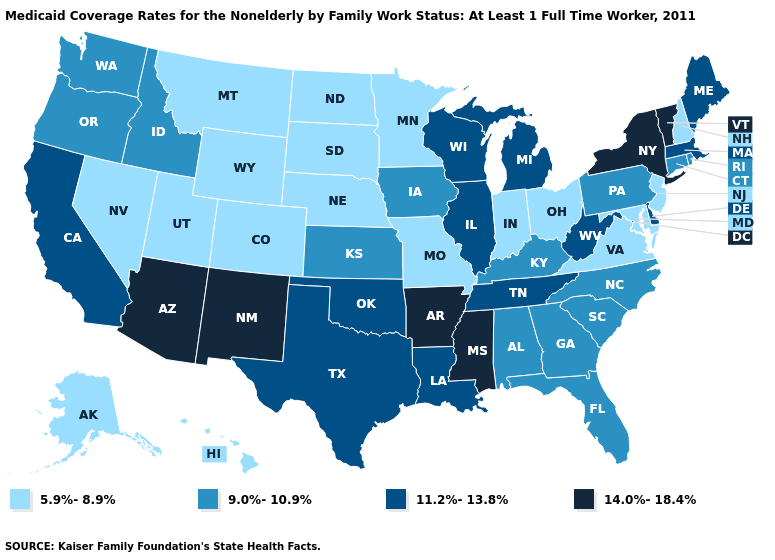Name the states that have a value in the range 11.2%-13.8%?
Quick response, please. California, Delaware, Illinois, Louisiana, Maine, Massachusetts, Michigan, Oklahoma, Tennessee, Texas, West Virginia, Wisconsin. How many symbols are there in the legend?
Quick response, please. 4. Does Kansas have the lowest value in the USA?
Write a very short answer. No. Which states have the lowest value in the West?
Be succinct. Alaska, Colorado, Hawaii, Montana, Nevada, Utah, Wyoming. Does Illinois have a higher value than Michigan?
Concise answer only. No. Name the states that have a value in the range 11.2%-13.8%?
Quick response, please. California, Delaware, Illinois, Louisiana, Maine, Massachusetts, Michigan, Oklahoma, Tennessee, Texas, West Virginia, Wisconsin. Does New Hampshire have the lowest value in the USA?
Be succinct. Yes. Does Oregon have a higher value than Ohio?
Answer briefly. Yes. Among the states that border California , does Oregon have the highest value?
Be succinct. No. What is the lowest value in the USA?
Short answer required. 5.9%-8.9%. What is the value of New York?
Give a very brief answer. 14.0%-18.4%. What is the lowest value in the Northeast?
Answer briefly. 5.9%-8.9%. Does Hawaii have a higher value than Maryland?
Quick response, please. No. Does New York have the highest value in the USA?
Be succinct. Yes. Which states have the lowest value in the Northeast?
Concise answer only. New Hampshire, New Jersey. 